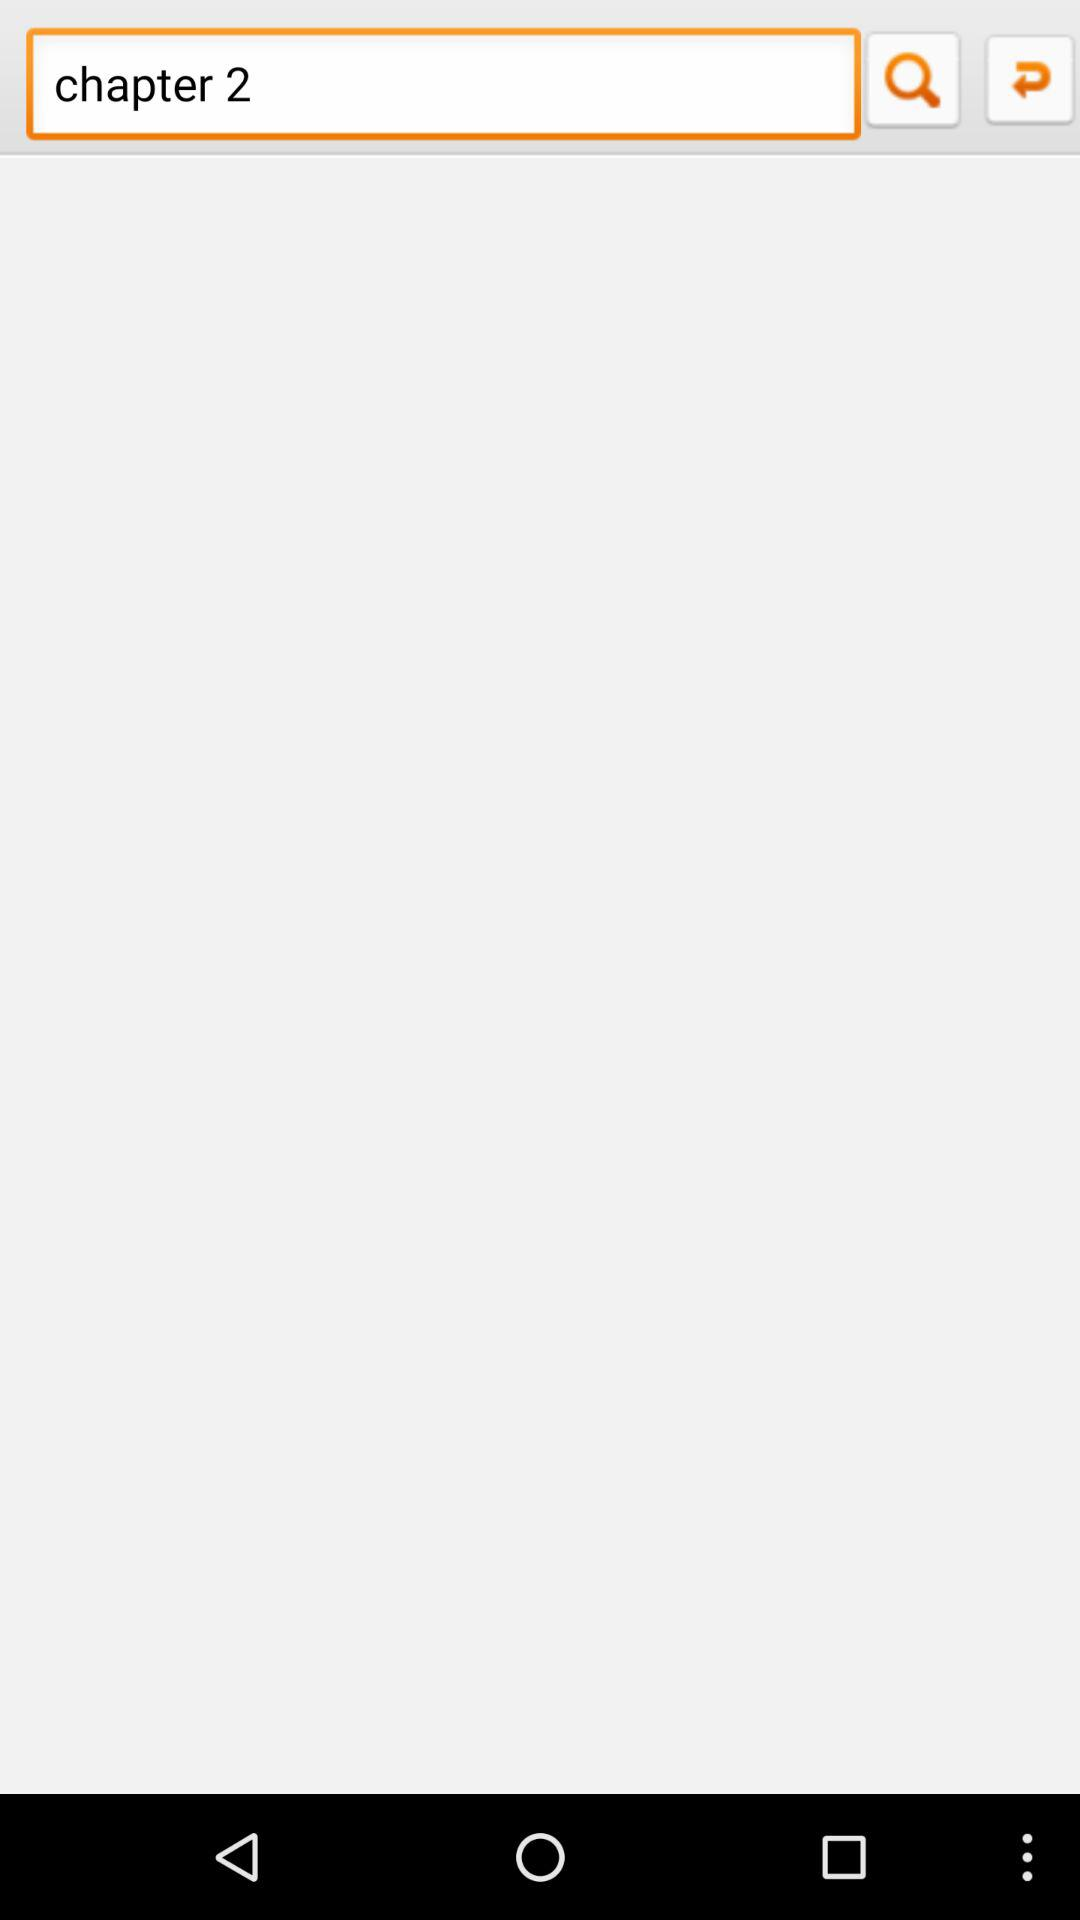What is the chapter number? The chapter number is 2. 